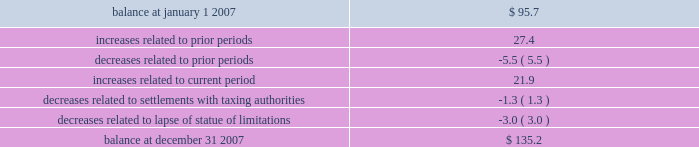In september 2007 , we reached a settlement with the united states department of justice in an ongoing investigation into financial relationships between major orthopaedic manufacturers and consulting orthopaedic surgeons .
Under the terms of the settlement , we paid a civil settlement amount of $ 169.5 million and we recorded an expense in that amount .
No tax benefit has been recorded related to the settlement expense due to the uncertainty as to the tax treatment .
We intend to pursue resolution of this uncertainty with taxing authorities , but are unable to ascertain the outcome or timing for such resolution at this time .
For more information regarding the settlement , see note 15 .
In june 2006 , the financial accounting standards board ( fasb ) issued interpretation no .
48 , accounting for uncertainty in income taxes 2013 an interpretation of fasb statement no .
109 , accounting for income taxes ( fin 48 ) .
Fin 48 addresses the determination of whether tax benefits claimed or expected to be claimed on a tax return should be recorded in the financial statements .
Under fin 48 , we may recognize the tax benefit from an uncertain tax position only if it is more likely than not that the tax position will be sustained on examination by the taxing authorities , based on the technical merits of the position .
The tax benefits recognized in the financial statements from such a position should be measured based on the largest benefit that has a greater than fifty percent likelihood of being realized upon ultimate settlement .
Fin 48 also provides guidance on derecognition , classification , interest and penalties on income taxes , accounting in interim periods and requires increased disclosures .
We adopted fin 48 on january 1 , 2007 .
Prior to the adoption of fin 48 we had a long term tax liability for expected settlement of various federal , state and foreign income tax liabilities that was reflected net of the corollary tax impact of these expected settlements of $ 102.1 million , as well as a separate accrued interest liability of $ 1.7 million .
As a result of the adoption of fin 48 , we are required to present the different components of such liability on a gross basis versus the historical net presentation .
The adoption resulted in the financial statement liability for unrecognized tax benefits decreasing by $ 6.4 million as of january 1 , 2007 .
The adoption resulted in this decrease in the liability as well as a reduction to retained earnings of $ 4.8 million , a reduction in goodwill of $ 61.4 million , the establishment of a tax receivable of $ 58.2 million , which was recorded in other current and non-current assets on our consolidated balance sheet , and an increase in an interest/penalty payable of $ 7.9 million , all as of january 1 , 2007 .
Therefore , after the adoption of fin 48 , the amount of unrecognized tax benefits is $ 95.7 million as of january 1 , 2007 , of which $ 28.6 million would impact our effective tax rate , if recognized .
The amount of unrecognized tax benefits is $ 135.2 million as of december 31 , 2007 .
Of this amount , $ 41.0 million would impact our effective tax rate , if recognized .
A reconciliation of the beginning and ending amounts of unrecognized tax benefits is as follows ( in millions ) : .
We recognize accrued interest and penalties related to unrecognized tax benefits in income tax expense in the consolidated statements of earnings , which is consistent with the recognition of these items in prior reporting periods .
As of january 1 , 2007 , we recorded a liability of $ 9.6 million for accrued interest and penalties , of which $ 7.5 million would impact our effective tax rate , if recognized .
The amount of this liability is $ 19.6 million as of december 31 , 2007 .
Of this amount , $ 14.7 million would impact our effective tax rate , if recognized .
We expect that the amount of tax liability for unrecognized tax benefits will change in the next twelve months ; however , we do not expect these changes will have a significant impact on our results of operations or financial position .
The u.s .
Federal statute of limitations remains open for the year 2003 and onward with years 2003 and 2004 currently under examination by the irs .
It is reasonably possible that a resolution with the irs for the years 2003 through 2004 will be reached within the next twelve months , but we do not anticipate this would result in any material impact on our financial position .
In addition , for the 1999 tax year of centerpulse , which we acquired in october 2003 , one issue remains in dispute .
The resolution of this issue would not impact our effective tax rate , as it would be recorded as an adjustment to goodwill .
State income tax returns are generally subject to examination for a period of 3 to 5 years after filing of the respective return .
The state impact of any federal changes remains subject to examination by various states for a period of up to one year after formal notification to the states .
We have various state income tax returns in the process of examination , administrative appeals or litigation .
It is reasonably possible that such matters will be resolved in the next twelve months , but we do not anticipate that the resolution of these matters would result in any material impact on our results of operations or financial position .
Foreign jurisdictions have statutes of limitations generally ranging from 3 to 5 years .
Years still open to examination by foreign tax authorities in major jurisdictions include australia ( 2003 onward ) , canada ( 1999 onward ) , france ( 2005 onward ) , germany ( 2005 onward ) , italy ( 2003 onward ) , japan ( 2001 onward ) , puerto rico ( 2005 onward ) , singapore ( 2003 onward ) , switzerland ( 2004 onward ) , and the united kingdom ( 2005 onward ) .
Z i m m e r h o l d i n g s , i n c .
2 0 0 7 f o r m 1 0 - k a n n u a l r e p o r t notes to consolidated financial statements ( continued ) .
What was the percentage change in unrecognized tax benefits for 2007? 
Computations: ((135.2 - 95.7) / 95.7)
Answer: 0.41275. 